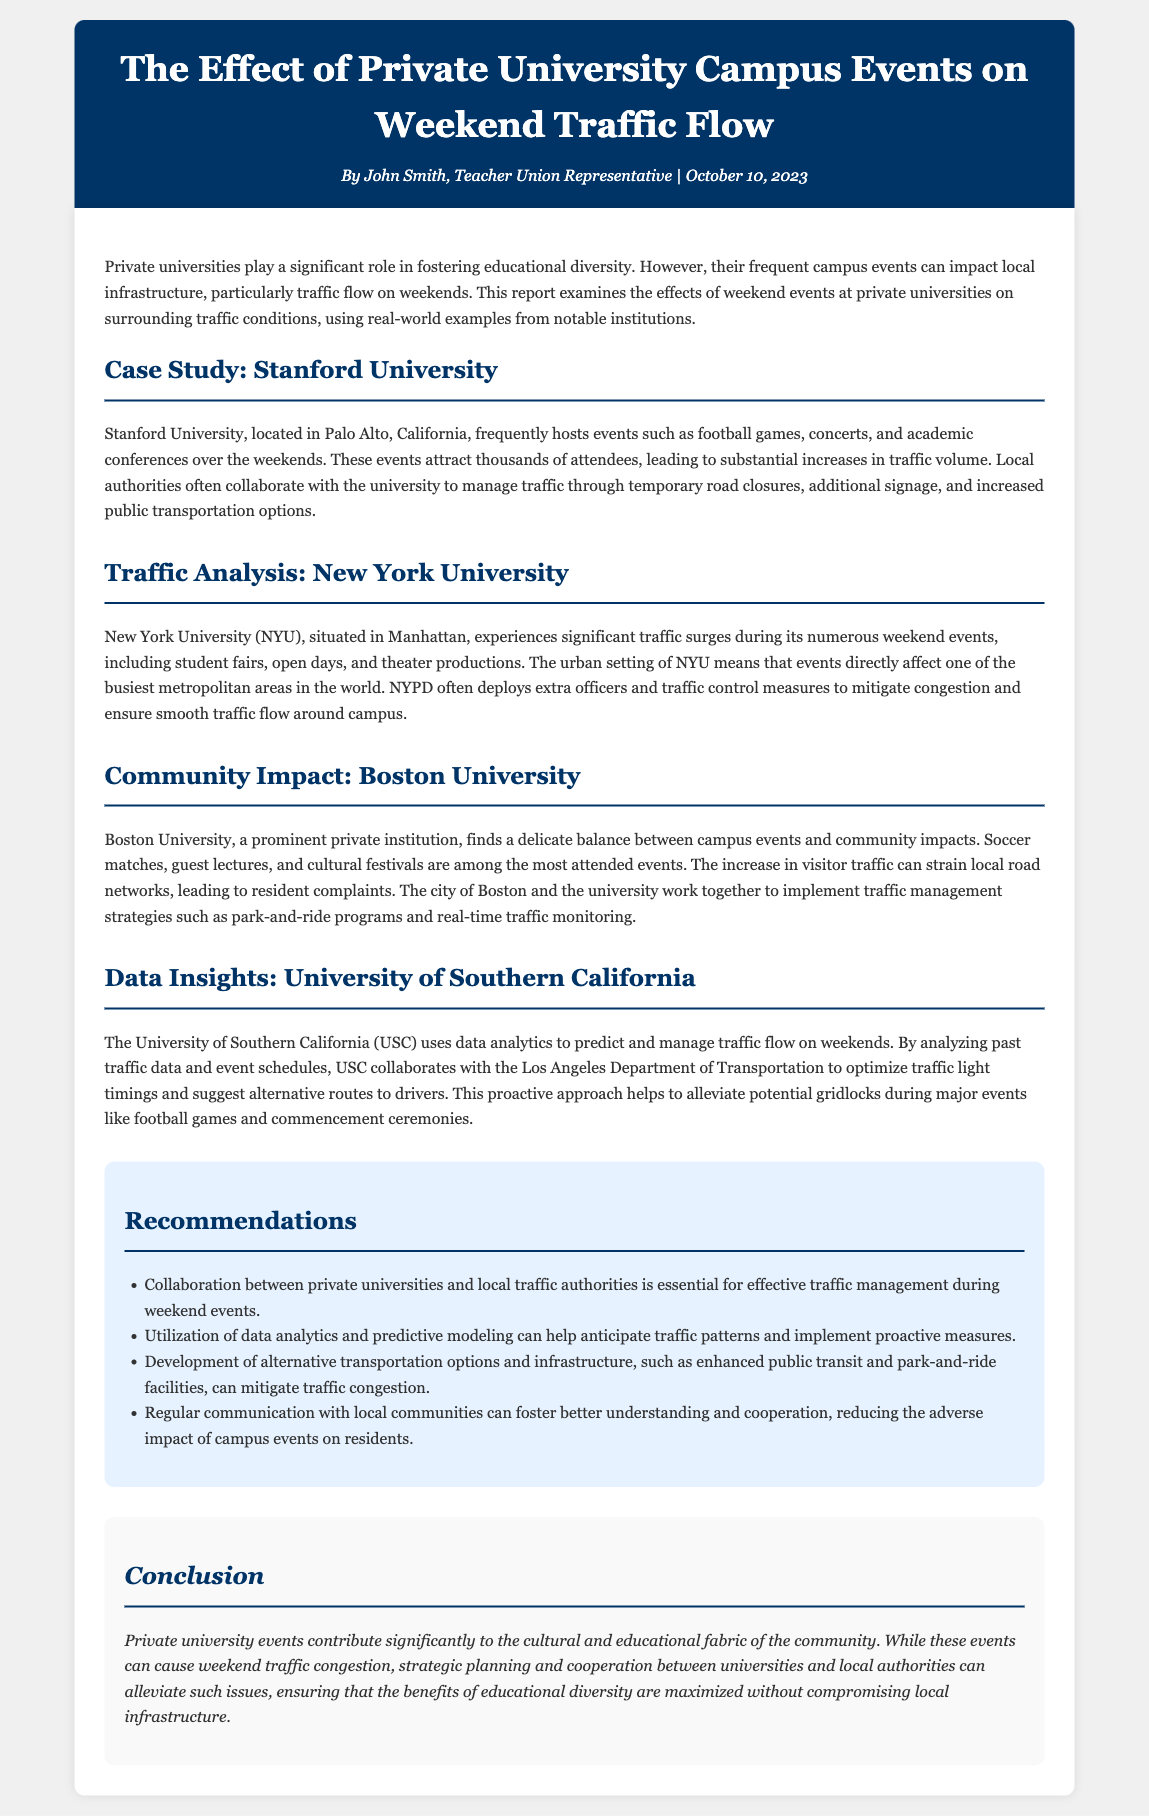What is the title of the report? The title of the report is mentioned at the top of the document.
Answer: The Effect of Private University Campus Events on Weekend Traffic Flow Who authored the report? The author of the report is specified in the header section.
Answer: John Smith Which university is used as a case study in the document? The document includes a case study of a specific university as part of the analysis.
Answer: Stanford University What type of events lead to increased traffic at private universities? The report lists specific event types that cause traffic surges.
Answer: Football games, concerts, and academic conferences What is one strategy recommended for traffic management during events? The document provides a list of recommendations for effectively managing traffic.
Answer: Collaboration between private universities and local traffic authorities Which department collaborates with USC for traffic management? The collaboration specifics for traffic management are mentioned in the data insights section.
Answer: Los Angeles Department of Transportation What is a common commuter concern regarding events at Boston University? The document addresses community concerns raised due to the increased traffic from events.
Answer: Resident complaints 